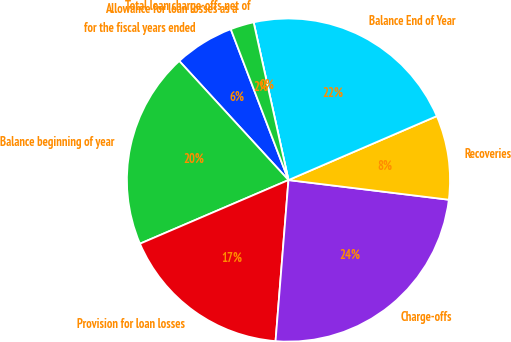<chart> <loc_0><loc_0><loc_500><loc_500><pie_chart><fcel>for the fiscal years ended<fcel>Balance beginning of year<fcel>Provision for loan losses<fcel>Charge-offs<fcel>Recoveries<fcel>Balance End of Year<fcel>Total loan charge-offs net of<fcel>Allowance for loan losses as a<nl><fcel>6.0%<fcel>19.63%<fcel>17.28%<fcel>24.33%<fcel>8.42%<fcel>21.98%<fcel>0.0%<fcel>2.35%<nl></chart> 